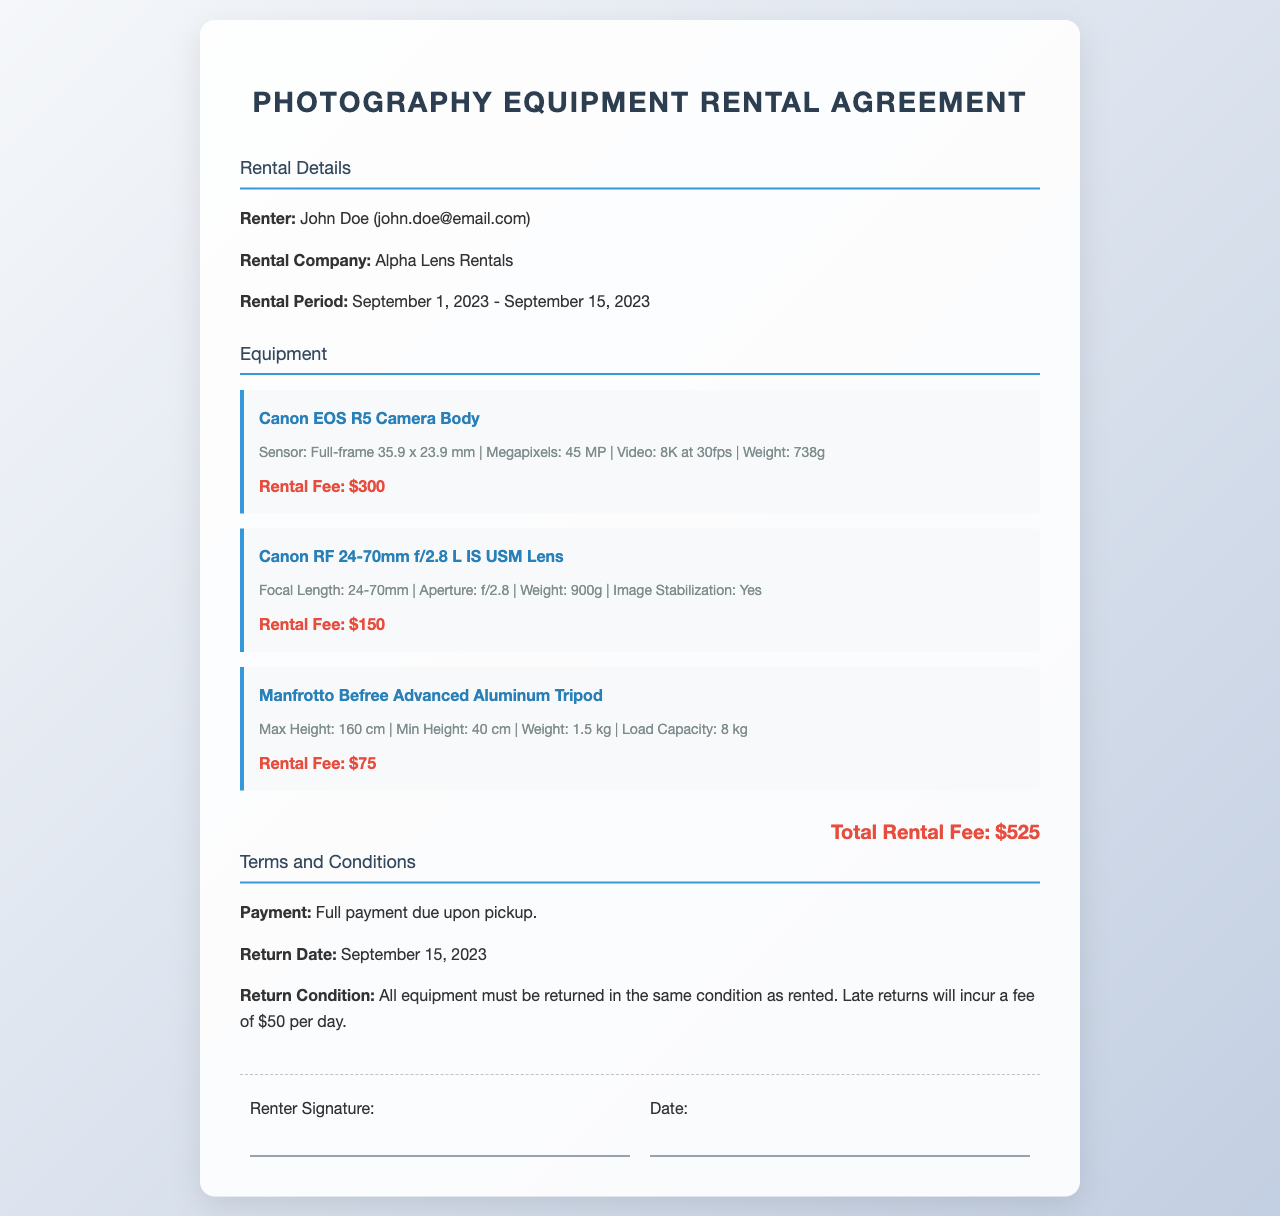What is the rental period? The rental period is specified as September 1, 2023 - September 15, 2023.
Answer: September 1, 2023 - September 15, 2023 Who is the renter? The renter's name is given in the document.
Answer: John Doe What is the rental fee for the Canon EOS R5 Camera Body? The fee for the Canon EOS R5 Camera Body is listed in the equipment section.
Answer: $300 What is the total rental fee? The total rental fee is calculated as the sum of all individual rental fees.
Answer: $525 What happens if equipment is returned late? The conditions for late returns are stated in the terms and conditions.
Answer: $50 per day 